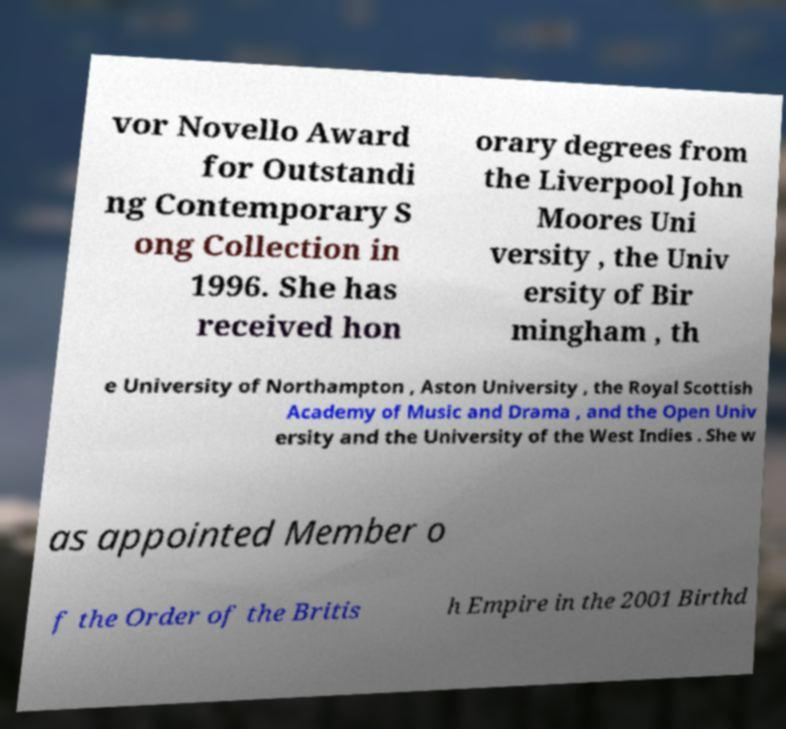For documentation purposes, I need the text within this image transcribed. Could you provide that? vor Novello Award for Outstandi ng Contemporary S ong Collection in 1996. She has received hon orary degrees from the Liverpool John Moores Uni versity , the Univ ersity of Bir mingham , th e University of Northampton , Aston University , the Royal Scottish Academy of Music and Drama , and the Open Univ ersity and the University of the West Indies . She w as appointed Member o f the Order of the Britis h Empire in the 2001 Birthd 